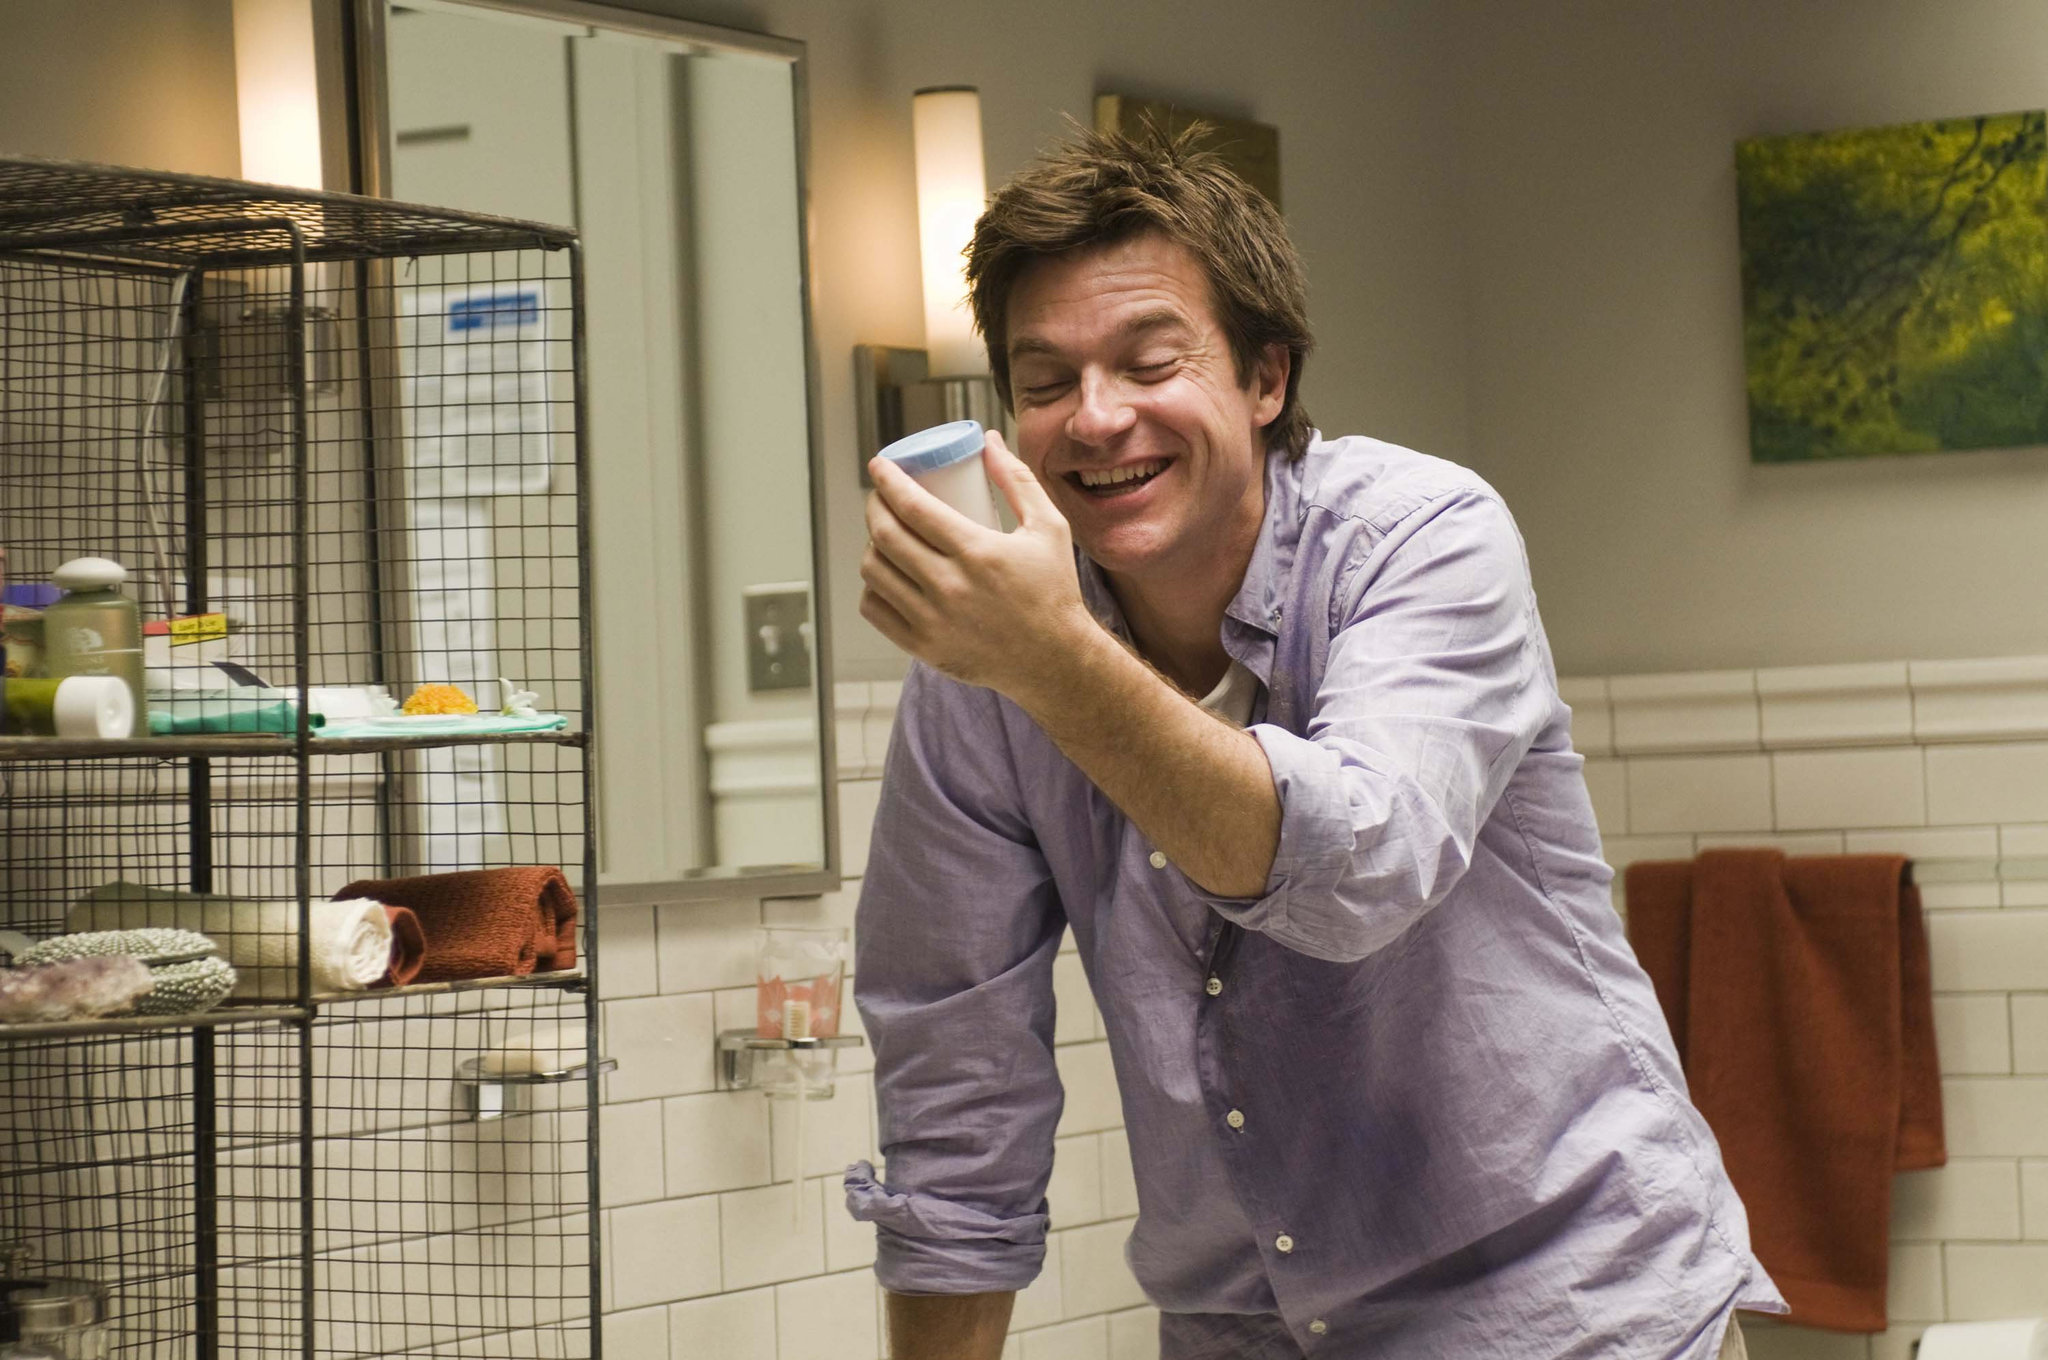What's the story behind the painting of the tree? The painting of the tree, vividly green and full of life, might be a reflection of the man’s love for nature and tranquility. Perhaps it's a cherished piece, a reminder of a childhood treehouse or a favorite spot in a park where he spent many hours dreaming and contemplating life. The artwork not only brings a breath of fresh air into the bathroom but also serves as a personal piece of history, a constant in his otherwise ever-changing surroundings. Imagine the bird in the birdcage could talk. What would it say about its life in the bathroom? If the yellow bird could talk, it might chirp about the peculiar yet cozy confines of its life in the bathroom. It would recount the man's melodious shower sing-alongs and the daily symphony of morning routines. The bird would narrate tales of the aromatic adventures it witnesses, from the fragrant fragrances of soaps to the eclectic array of toiletries. It might express surprise at its unusual home but also contentment, enjoying the man's company and the leafy serenity projected by the painting of the tree on the wall. 